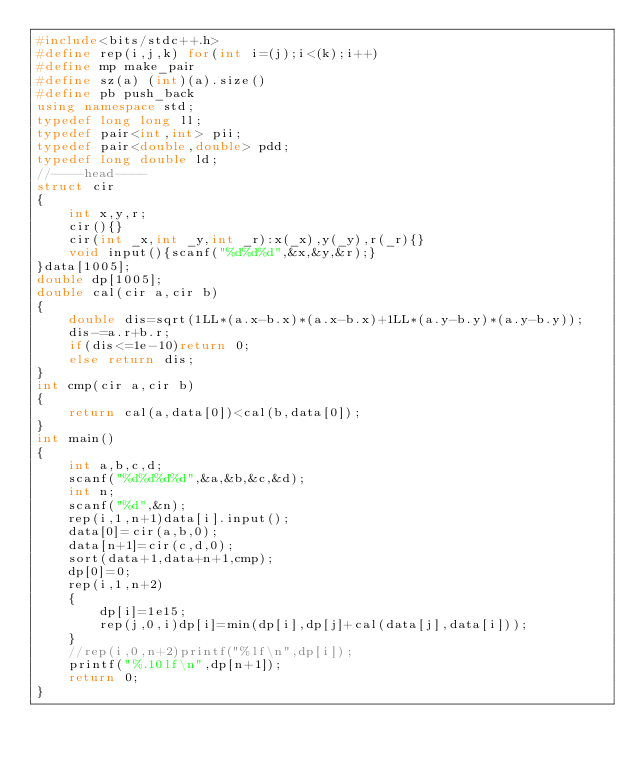<code> <loc_0><loc_0><loc_500><loc_500><_C++_>#include<bits/stdc++.h>
#define rep(i,j,k) for(int i=(j);i<(k);i++)
#define mp make_pair
#define sz(a) (int)(a).size()
#define pb push_back
using namespace std;
typedef long long ll;
typedef pair<int,int> pii;
typedef pair<double,double> pdd;
typedef long double ld;
//----head----
struct cir
{
	int x,y,r;
	cir(){}
	cir(int _x,int _y,int _r):x(_x),y(_y),r(_r){}
	void input(){scanf("%d%d%d",&x,&y,&r);}
}data[1005];
double dp[1005];
double cal(cir a,cir b)
{
	double dis=sqrt(1LL*(a.x-b.x)*(a.x-b.x)+1LL*(a.y-b.y)*(a.y-b.y));
	dis-=a.r+b.r;
	if(dis<=1e-10)return 0;
	else return dis;
}
int cmp(cir a,cir b)
{
	return cal(a,data[0])<cal(b,data[0]);
}
int main()
{
	int a,b,c,d;
	scanf("%d%d%d%d",&a,&b,&c,&d);
	int n;
	scanf("%d",&n);
	rep(i,1,n+1)data[i].input();
	data[0]=cir(a,b,0);
	data[n+1]=cir(c,d,0);
	sort(data+1,data+n+1,cmp);
	dp[0]=0;
	rep(i,1,n+2)
	{
		dp[i]=1e15;
		rep(j,0,i)dp[i]=min(dp[i],dp[j]+cal(data[j],data[i]));
	}
	//rep(i,0,n+2)printf("%lf\n",dp[i]);
	printf("%.10lf\n",dp[n+1]);
	return 0;
}
</code> 